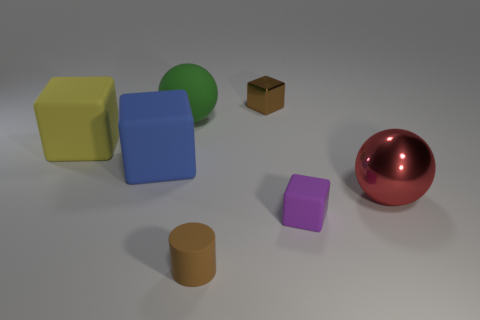Subtract all brown blocks. How many blocks are left? 3 Add 1 tiny brown matte cylinders. How many objects exist? 8 Subtract all purple cubes. How many cubes are left? 3 Subtract all spheres. How many objects are left? 5 Subtract 1 yellow blocks. How many objects are left? 6 Subtract 1 cylinders. How many cylinders are left? 0 Subtract all blue cylinders. Subtract all red balls. How many cylinders are left? 1 Subtract all yellow cubes. How many purple cylinders are left? 0 Subtract all shiny blocks. Subtract all brown metal blocks. How many objects are left? 5 Add 2 large rubber blocks. How many large rubber blocks are left? 4 